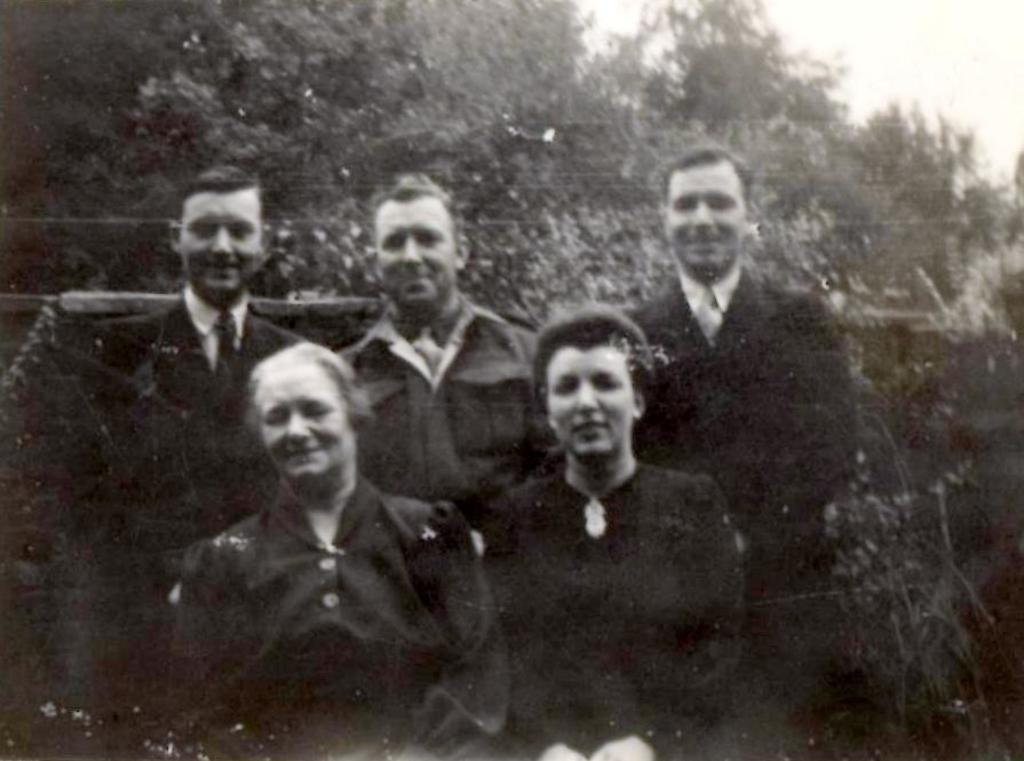What is the main subject of the image? There are people in the center of the image. What can be seen in the background of the image? There are trees and the sky visible in the background of the image. What degree does the person in the image have? There is no information about the person's degree in the image. Can you hear the person in the image laughing? The image is a still picture, so we cannot hear any sounds, including laughter. 